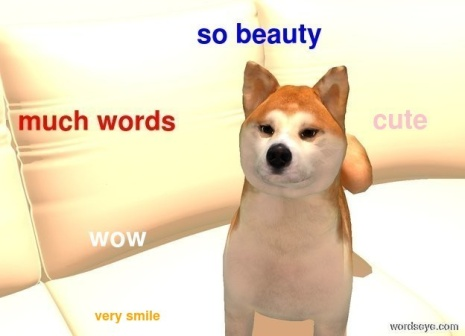What emotions do you think the dog is experiencing in this moment? The Shiba Inu dog in the image seems to be experiencing a mix of curiosity and attentiveness. The head tilt is a common gesture in dogs that often indicates they're trying to focus on a particular sound or sight. Combined with the playful text overlay, it creates an impression that the dog is engaged and perhaps a bit amused by its surroundings. How would you describe the personality of this dog based on the image? Based on the image, the Shiba Inu appears to have a charming and playful personality. The head tilt and the phrases like "so beauty" and "very smile" suggest a cheerful and friendly demeanor. Shiba Inus are known for being spirited and clever, and this dog seems to embody those traits with its engaging and inquisitive expression. Its comfortable position on the white couch adds to the sense of being at ease and content. Imagine a day in the life of this Shiba Inu. Describe it in detail. In a typical day, this Shiba Inu wakes up early, stretching and yawning as the morning sun filters through the windows. After a hearty breakfast of premium dog food, it spends some time playing with its favorite toys. Mid-morning, it enjoys a leisurely walk around the neighborhood, sniffing every interesting scent and greeting fellow dogs and their owners with a friendly wag of the tail.

Upon returning home, it's time for a nap on the comfortable white couch, basking in the warm glow of sunlight. As the afternoon progresses, the dog engages in a bit of mischief, perhaps chasing a squirrel in the backyard or playing tug-of-war with its favorite human. Dinner time is another highlight, followed by a relaxed evening cuddle session. As night falls, the Shiba Inu curl up in its cozy bed, drifting off to sleep with dreams of the day's adventures. 